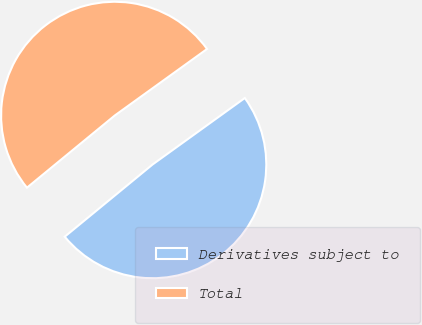Convert chart to OTSL. <chart><loc_0><loc_0><loc_500><loc_500><pie_chart><fcel>Derivatives subject to<fcel>Total<nl><fcel>48.99%<fcel>51.01%<nl></chart> 